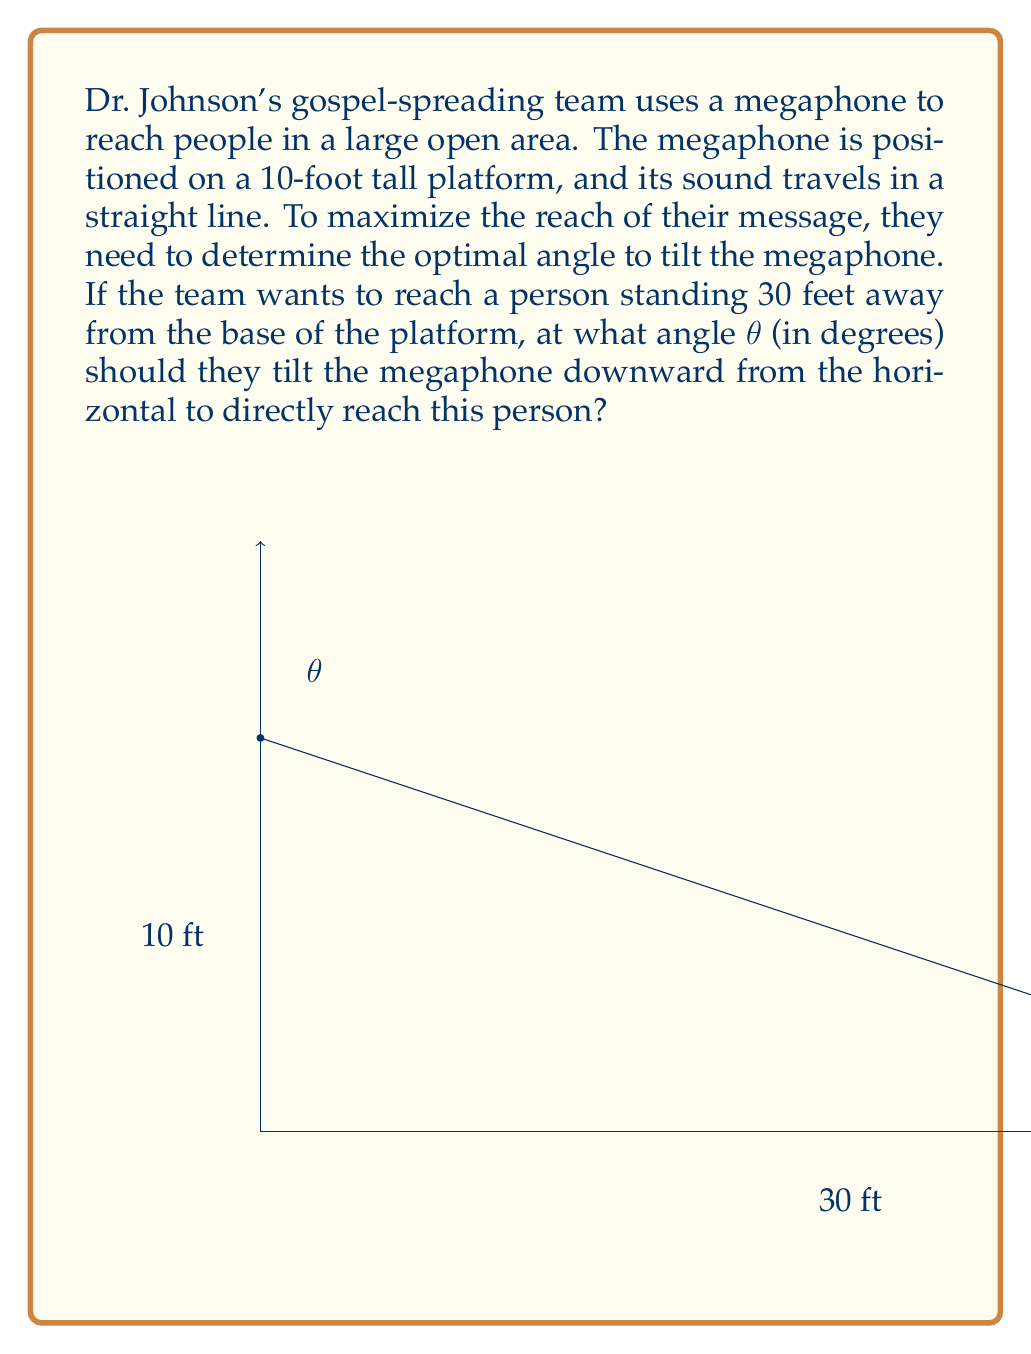Help me with this question. To solve this problem, we'll use trigonometry:

1) First, let's visualize the scenario as a right triangle. The platform height forms one side (10 ft), the distance to the person forms the base (30 ft), and the sound path forms the hypotenuse.

2) We need to find the angle θ between the horizontal and the hypotenuse (sound path).

3) We can use the arctangent function to find this angle. The tangent of an angle is the opposite side divided by the adjacent side.

4) In this case:
   opposite = platform height = 10 ft
   adjacent = distance to person = 30 ft

5) So, we can set up the equation:

   $$\tan(\theta) = \frac{\text{opposite}}{\text{adjacent}} = \frac{10}{30}$$

6) To solve for θ, we take the arctangent (inverse tangent) of both sides:

   $$\theta = \arctan(\frac{10}{30})$$

7) Using a calculator or computer:

   $$\theta = \arctan(0.3333...) \approx 18.4349...$$

8) Rounding to two decimal places:

   $$\theta \approx 18.43\text{ degrees}$$

This is the angle at which the megaphone should be tilted downward from the horizontal to directly reach the person 30 feet away.
Answer: 18.43° 